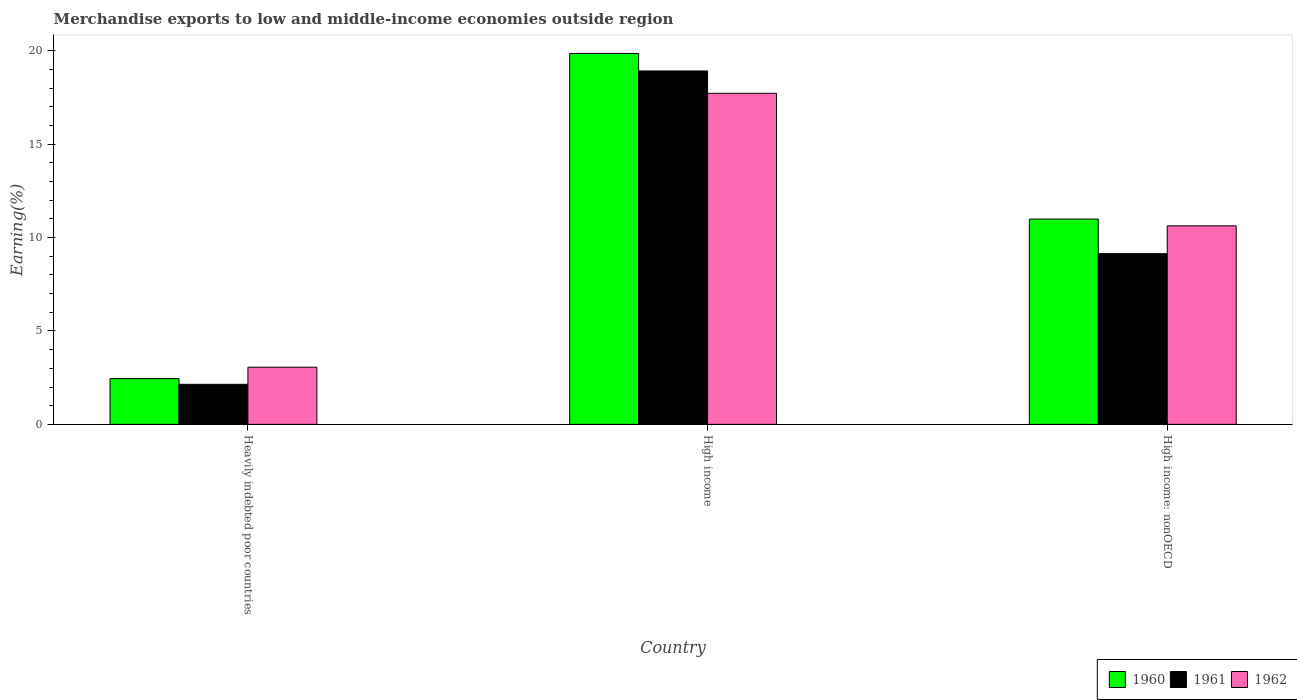Are the number of bars per tick equal to the number of legend labels?
Provide a short and direct response. Yes. How many bars are there on the 3rd tick from the right?
Your response must be concise. 3. What is the label of the 1st group of bars from the left?
Offer a very short reply. Heavily indebted poor countries. What is the percentage of amount earned from merchandise exports in 1962 in High income?
Provide a succinct answer. 17.72. Across all countries, what is the maximum percentage of amount earned from merchandise exports in 1961?
Your response must be concise. 18.92. Across all countries, what is the minimum percentage of amount earned from merchandise exports in 1960?
Keep it short and to the point. 2.45. In which country was the percentage of amount earned from merchandise exports in 1960 maximum?
Give a very brief answer. High income. In which country was the percentage of amount earned from merchandise exports in 1962 minimum?
Offer a terse response. Heavily indebted poor countries. What is the total percentage of amount earned from merchandise exports in 1960 in the graph?
Make the answer very short. 33.29. What is the difference between the percentage of amount earned from merchandise exports in 1960 in High income and that in High income: nonOECD?
Ensure brevity in your answer.  8.87. What is the difference between the percentage of amount earned from merchandise exports in 1962 in Heavily indebted poor countries and the percentage of amount earned from merchandise exports in 1960 in High income?
Offer a terse response. -16.8. What is the average percentage of amount earned from merchandise exports in 1960 per country?
Ensure brevity in your answer.  11.1. What is the difference between the percentage of amount earned from merchandise exports of/in 1962 and percentage of amount earned from merchandise exports of/in 1960 in High income: nonOECD?
Make the answer very short. -0.36. In how many countries, is the percentage of amount earned from merchandise exports in 1961 greater than 16 %?
Your answer should be compact. 1. What is the ratio of the percentage of amount earned from merchandise exports in 1961 in High income to that in High income: nonOECD?
Offer a very short reply. 2.07. What is the difference between the highest and the second highest percentage of amount earned from merchandise exports in 1962?
Keep it short and to the point. 7.1. What is the difference between the highest and the lowest percentage of amount earned from merchandise exports in 1960?
Make the answer very short. 17.41. Is the sum of the percentage of amount earned from merchandise exports in 1960 in Heavily indebted poor countries and High income greater than the maximum percentage of amount earned from merchandise exports in 1962 across all countries?
Offer a terse response. Yes. Is it the case that in every country, the sum of the percentage of amount earned from merchandise exports in 1961 and percentage of amount earned from merchandise exports in 1960 is greater than the percentage of amount earned from merchandise exports in 1962?
Offer a very short reply. Yes. Are all the bars in the graph horizontal?
Your response must be concise. No. What is the difference between two consecutive major ticks on the Y-axis?
Your answer should be compact. 5. Are the values on the major ticks of Y-axis written in scientific E-notation?
Keep it short and to the point. No. Does the graph contain grids?
Keep it short and to the point. No. How many legend labels are there?
Your answer should be compact. 3. How are the legend labels stacked?
Keep it short and to the point. Horizontal. What is the title of the graph?
Offer a very short reply. Merchandise exports to low and middle-income economies outside region. What is the label or title of the X-axis?
Give a very brief answer. Country. What is the label or title of the Y-axis?
Ensure brevity in your answer.  Earning(%). What is the Earning(%) in 1960 in Heavily indebted poor countries?
Ensure brevity in your answer.  2.45. What is the Earning(%) in 1961 in Heavily indebted poor countries?
Provide a short and direct response. 2.14. What is the Earning(%) in 1962 in Heavily indebted poor countries?
Provide a succinct answer. 3.06. What is the Earning(%) of 1960 in High income?
Ensure brevity in your answer.  19.86. What is the Earning(%) in 1961 in High income?
Your answer should be compact. 18.92. What is the Earning(%) in 1962 in High income?
Ensure brevity in your answer.  17.72. What is the Earning(%) in 1960 in High income: nonOECD?
Offer a terse response. 10.99. What is the Earning(%) of 1961 in High income: nonOECD?
Give a very brief answer. 9.14. What is the Earning(%) of 1962 in High income: nonOECD?
Give a very brief answer. 10.63. Across all countries, what is the maximum Earning(%) in 1960?
Your answer should be very brief. 19.86. Across all countries, what is the maximum Earning(%) in 1961?
Your response must be concise. 18.92. Across all countries, what is the maximum Earning(%) of 1962?
Offer a terse response. 17.72. Across all countries, what is the minimum Earning(%) of 1960?
Give a very brief answer. 2.45. Across all countries, what is the minimum Earning(%) in 1961?
Your response must be concise. 2.14. Across all countries, what is the minimum Earning(%) in 1962?
Provide a short and direct response. 3.06. What is the total Earning(%) in 1960 in the graph?
Ensure brevity in your answer.  33.3. What is the total Earning(%) of 1961 in the graph?
Your response must be concise. 30.2. What is the total Earning(%) in 1962 in the graph?
Ensure brevity in your answer.  31.41. What is the difference between the Earning(%) of 1960 in Heavily indebted poor countries and that in High income?
Offer a terse response. -17.41. What is the difference between the Earning(%) in 1961 in Heavily indebted poor countries and that in High income?
Your response must be concise. -16.77. What is the difference between the Earning(%) of 1962 in Heavily indebted poor countries and that in High income?
Offer a very short reply. -14.66. What is the difference between the Earning(%) of 1960 in Heavily indebted poor countries and that in High income: nonOECD?
Provide a succinct answer. -8.54. What is the difference between the Earning(%) of 1961 in Heavily indebted poor countries and that in High income: nonOECD?
Keep it short and to the point. -6.99. What is the difference between the Earning(%) in 1962 in Heavily indebted poor countries and that in High income: nonOECD?
Make the answer very short. -7.57. What is the difference between the Earning(%) of 1960 in High income and that in High income: nonOECD?
Make the answer very short. 8.87. What is the difference between the Earning(%) of 1961 in High income and that in High income: nonOECD?
Keep it short and to the point. 9.78. What is the difference between the Earning(%) of 1962 in High income and that in High income: nonOECD?
Keep it short and to the point. 7.1. What is the difference between the Earning(%) in 1960 in Heavily indebted poor countries and the Earning(%) in 1961 in High income?
Provide a succinct answer. -16.47. What is the difference between the Earning(%) in 1960 in Heavily indebted poor countries and the Earning(%) in 1962 in High income?
Give a very brief answer. -15.27. What is the difference between the Earning(%) in 1961 in Heavily indebted poor countries and the Earning(%) in 1962 in High income?
Offer a terse response. -15.58. What is the difference between the Earning(%) in 1960 in Heavily indebted poor countries and the Earning(%) in 1961 in High income: nonOECD?
Provide a short and direct response. -6.69. What is the difference between the Earning(%) in 1960 in Heavily indebted poor countries and the Earning(%) in 1962 in High income: nonOECD?
Give a very brief answer. -8.18. What is the difference between the Earning(%) of 1961 in Heavily indebted poor countries and the Earning(%) of 1962 in High income: nonOECD?
Keep it short and to the point. -8.48. What is the difference between the Earning(%) of 1960 in High income and the Earning(%) of 1961 in High income: nonOECD?
Keep it short and to the point. 10.72. What is the difference between the Earning(%) of 1960 in High income and the Earning(%) of 1962 in High income: nonOECD?
Your answer should be compact. 9.23. What is the difference between the Earning(%) in 1961 in High income and the Earning(%) in 1962 in High income: nonOECD?
Provide a succinct answer. 8.29. What is the average Earning(%) in 1960 per country?
Keep it short and to the point. 11.1. What is the average Earning(%) of 1961 per country?
Give a very brief answer. 10.07. What is the average Earning(%) of 1962 per country?
Offer a very short reply. 10.47. What is the difference between the Earning(%) in 1960 and Earning(%) in 1961 in Heavily indebted poor countries?
Keep it short and to the point. 0.31. What is the difference between the Earning(%) of 1960 and Earning(%) of 1962 in Heavily indebted poor countries?
Provide a succinct answer. -0.61. What is the difference between the Earning(%) of 1961 and Earning(%) of 1962 in Heavily indebted poor countries?
Offer a very short reply. -0.92. What is the difference between the Earning(%) in 1960 and Earning(%) in 1961 in High income?
Provide a succinct answer. 0.94. What is the difference between the Earning(%) of 1960 and Earning(%) of 1962 in High income?
Ensure brevity in your answer.  2.13. What is the difference between the Earning(%) in 1961 and Earning(%) in 1962 in High income?
Keep it short and to the point. 1.2. What is the difference between the Earning(%) in 1960 and Earning(%) in 1961 in High income: nonOECD?
Provide a short and direct response. 1.85. What is the difference between the Earning(%) of 1960 and Earning(%) of 1962 in High income: nonOECD?
Keep it short and to the point. 0.36. What is the difference between the Earning(%) in 1961 and Earning(%) in 1962 in High income: nonOECD?
Your answer should be very brief. -1.49. What is the ratio of the Earning(%) in 1960 in Heavily indebted poor countries to that in High income?
Provide a succinct answer. 0.12. What is the ratio of the Earning(%) of 1961 in Heavily indebted poor countries to that in High income?
Keep it short and to the point. 0.11. What is the ratio of the Earning(%) in 1962 in Heavily indebted poor countries to that in High income?
Make the answer very short. 0.17. What is the ratio of the Earning(%) in 1960 in Heavily indebted poor countries to that in High income: nonOECD?
Your response must be concise. 0.22. What is the ratio of the Earning(%) in 1961 in Heavily indebted poor countries to that in High income: nonOECD?
Offer a very short reply. 0.23. What is the ratio of the Earning(%) of 1962 in Heavily indebted poor countries to that in High income: nonOECD?
Offer a terse response. 0.29. What is the ratio of the Earning(%) of 1960 in High income to that in High income: nonOECD?
Your response must be concise. 1.81. What is the ratio of the Earning(%) of 1961 in High income to that in High income: nonOECD?
Give a very brief answer. 2.07. What is the ratio of the Earning(%) in 1962 in High income to that in High income: nonOECD?
Keep it short and to the point. 1.67. What is the difference between the highest and the second highest Earning(%) in 1960?
Ensure brevity in your answer.  8.87. What is the difference between the highest and the second highest Earning(%) in 1961?
Give a very brief answer. 9.78. What is the difference between the highest and the second highest Earning(%) of 1962?
Keep it short and to the point. 7.1. What is the difference between the highest and the lowest Earning(%) of 1960?
Provide a short and direct response. 17.41. What is the difference between the highest and the lowest Earning(%) in 1961?
Your answer should be very brief. 16.77. What is the difference between the highest and the lowest Earning(%) of 1962?
Ensure brevity in your answer.  14.66. 